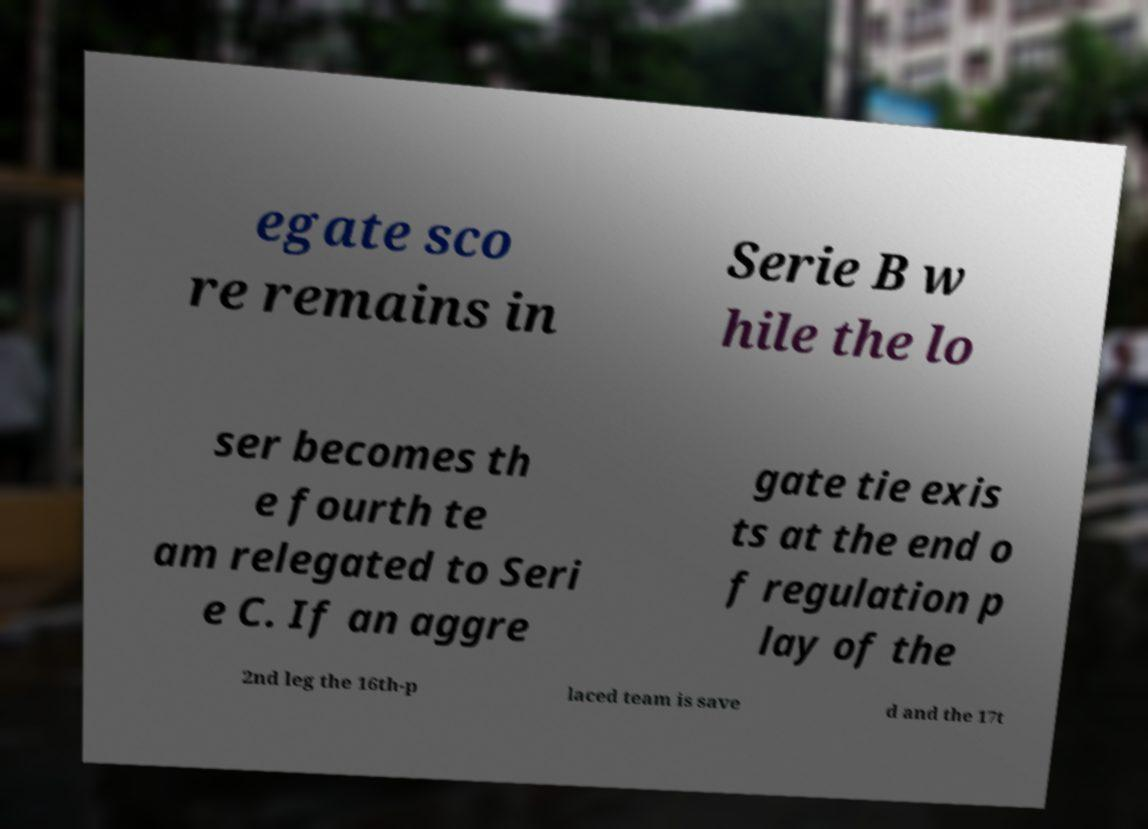Could you assist in decoding the text presented in this image and type it out clearly? egate sco re remains in Serie B w hile the lo ser becomes th e fourth te am relegated to Seri e C. If an aggre gate tie exis ts at the end o f regulation p lay of the 2nd leg the 16th-p laced team is save d and the 17t 